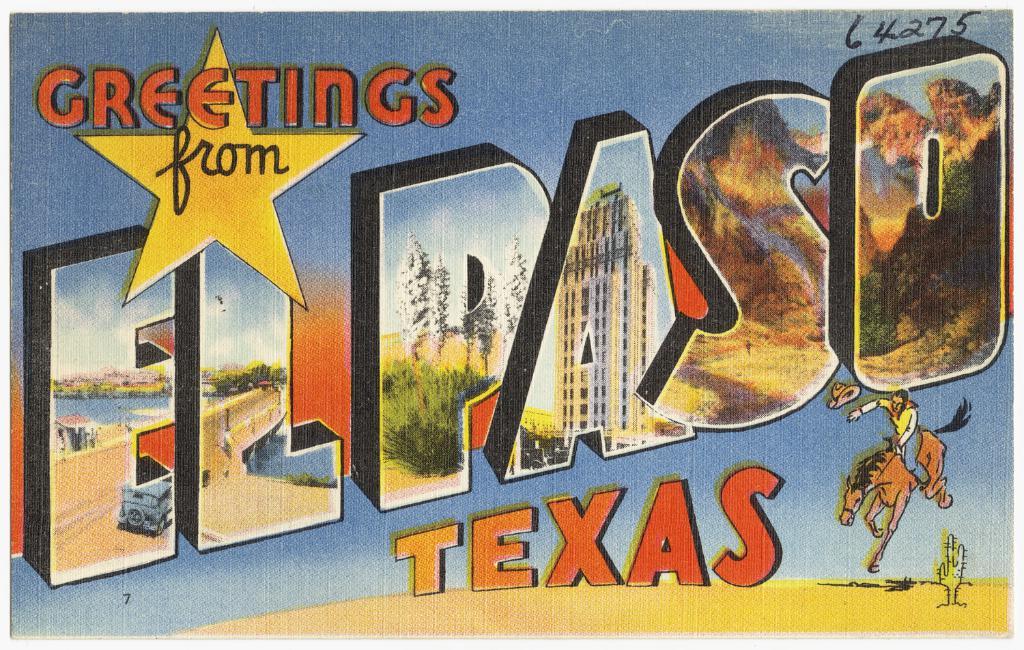Does el paso actually care about people entering?
Your answer should be compact. Unanswerable. What state is this greeting from?
Your response must be concise. Texas. 